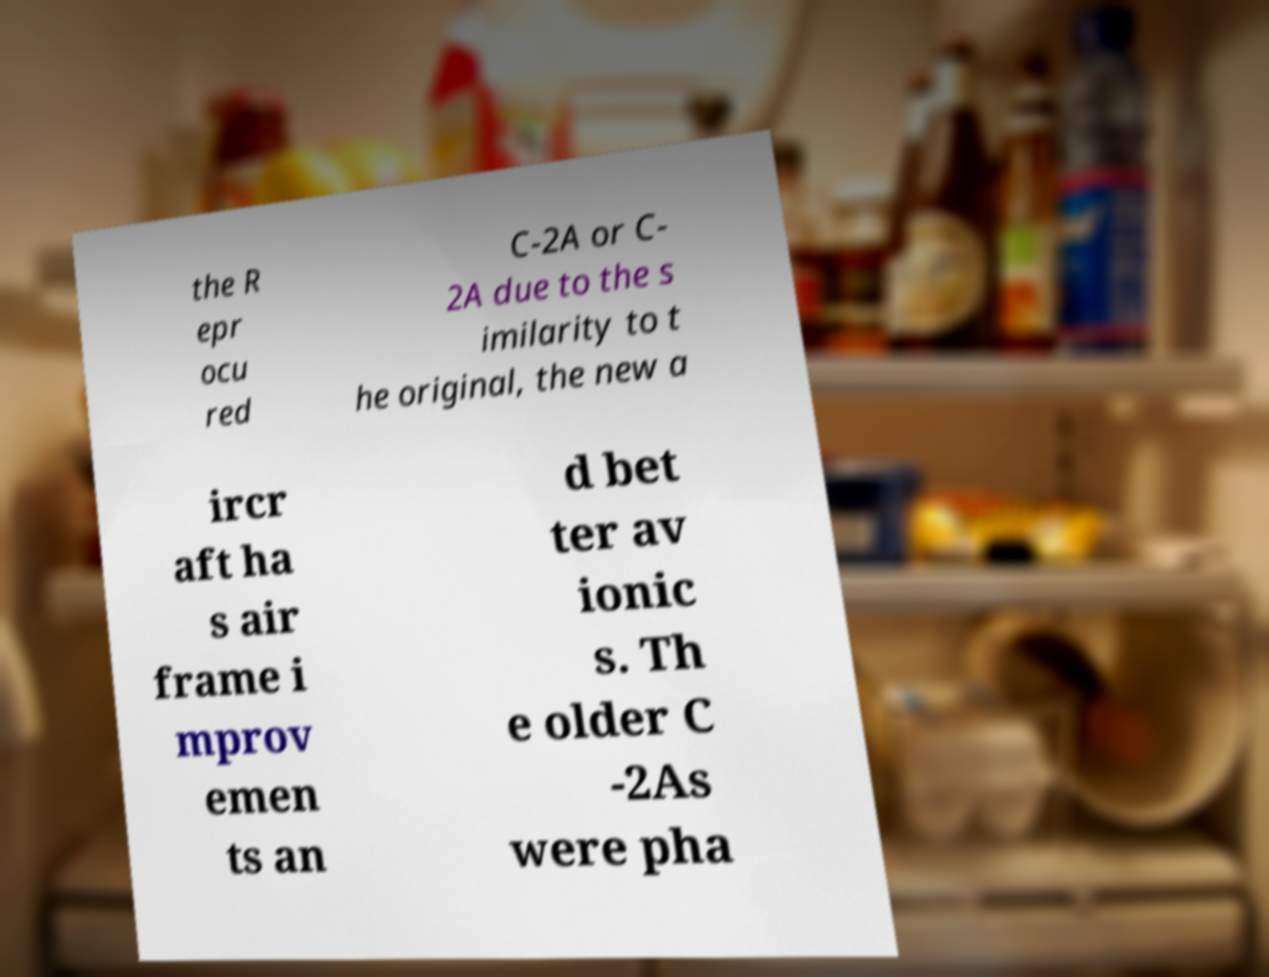What messages or text are displayed in this image? I need them in a readable, typed format. the R epr ocu red C-2A or C- 2A due to the s imilarity to t he original, the new a ircr aft ha s air frame i mprov emen ts an d bet ter av ionic s. Th e older C -2As were pha 